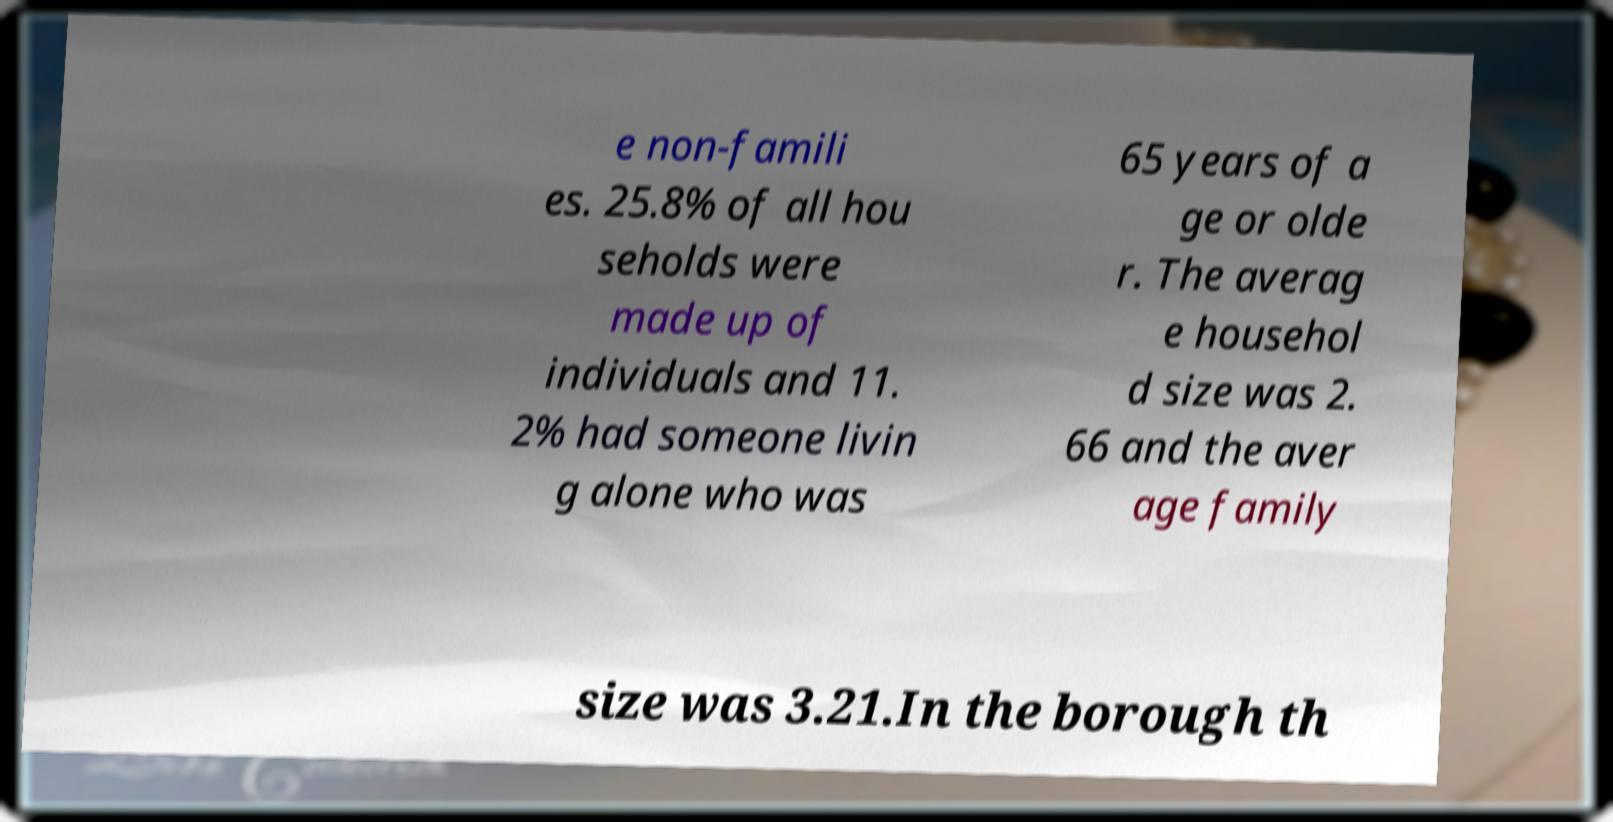Could you assist in decoding the text presented in this image and type it out clearly? e non-famili es. 25.8% of all hou seholds were made up of individuals and 11. 2% had someone livin g alone who was 65 years of a ge or olde r. The averag e househol d size was 2. 66 and the aver age family size was 3.21.In the borough th 